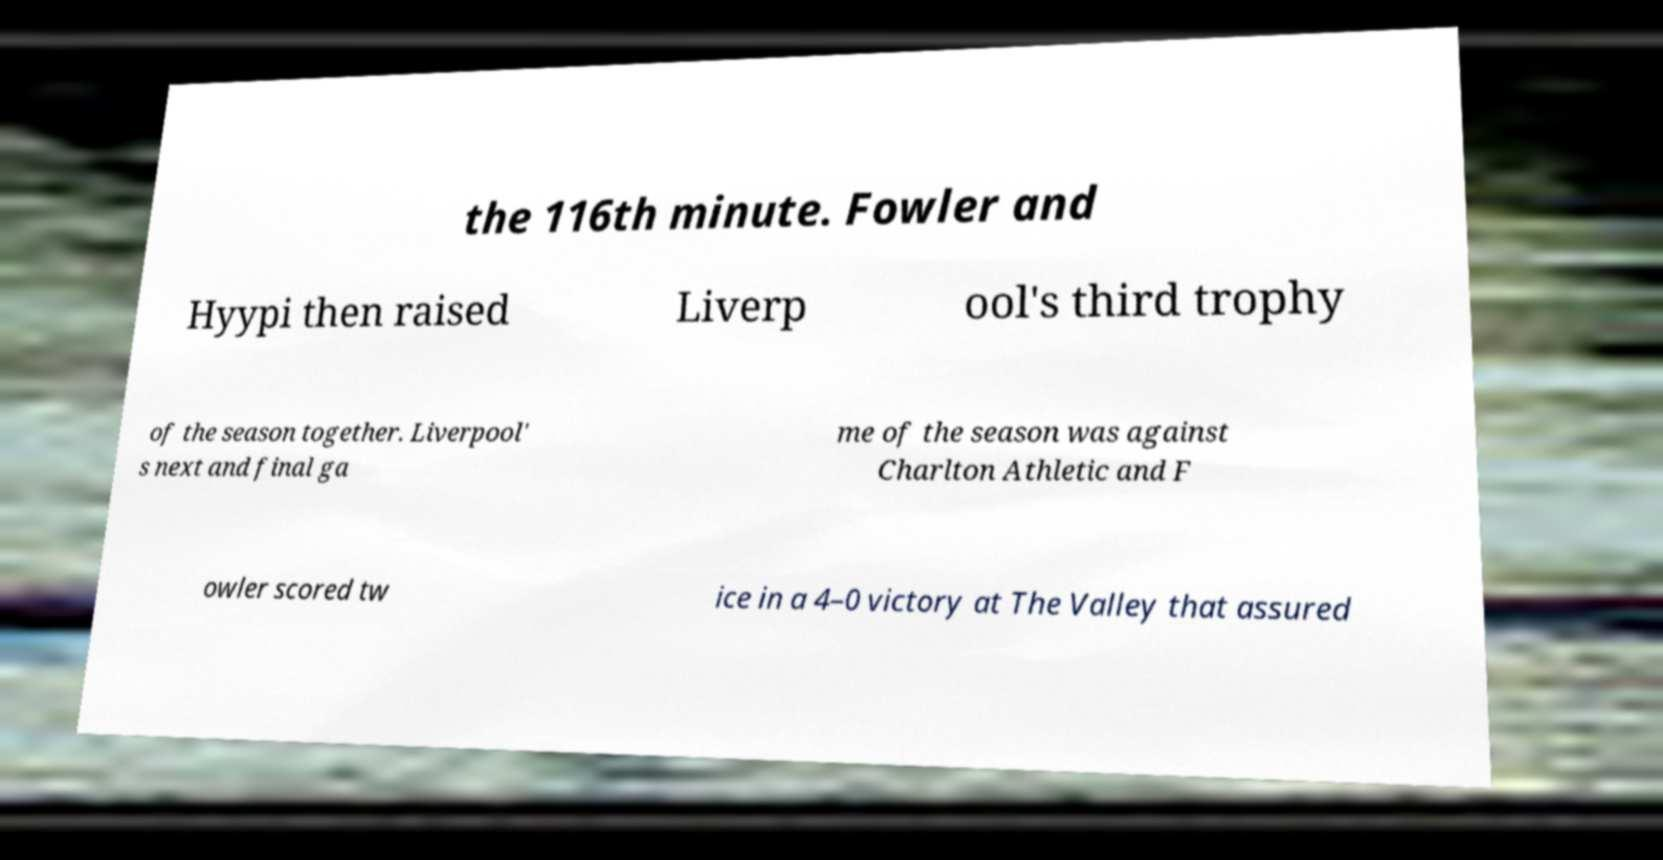Could you extract and type out the text from this image? the 116th minute. Fowler and Hyypi then raised Liverp ool's third trophy of the season together. Liverpool' s next and final ga me of the season was against Charlton Athletic and F owler scored tw ice in a 4–0 victory at The Valley that assured 